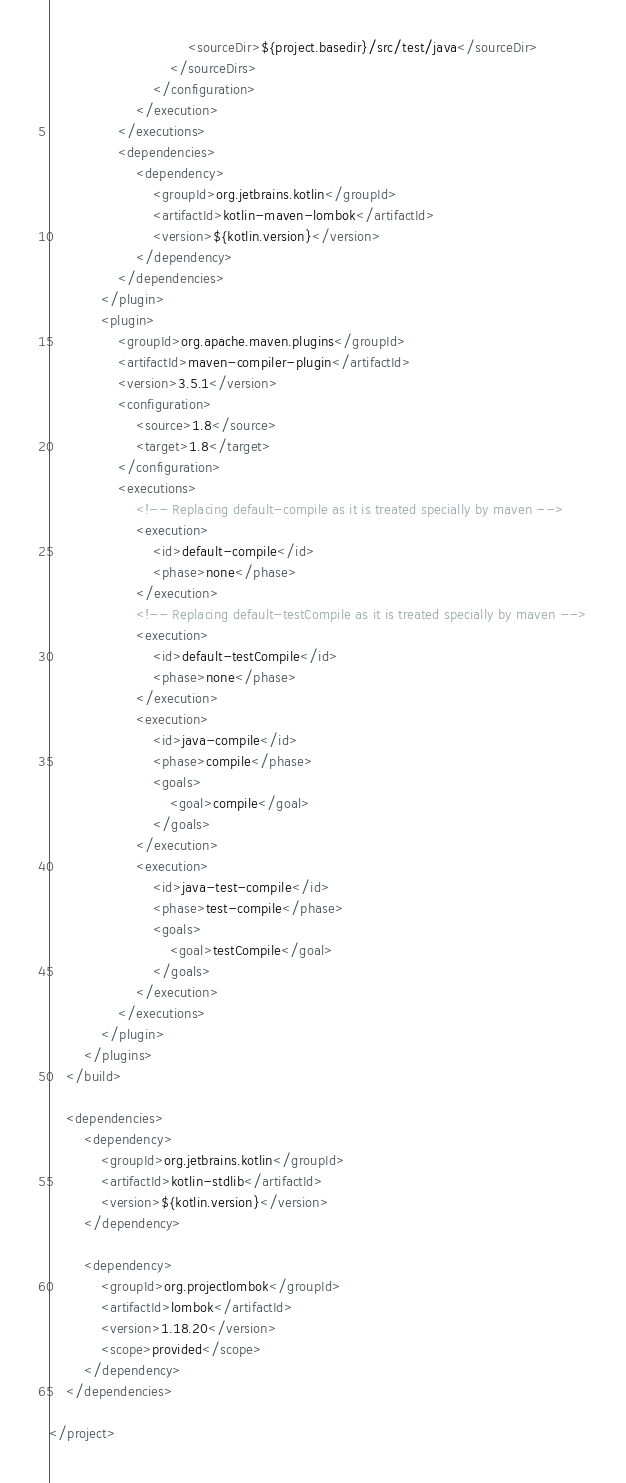Convert code to text. <code><loc_0><loc_0><loc_500><loc_500><_XML_>                                <sourceDir>${project.basedir}/src/test/java</sourceDir>
                            </sourceDirs>
                        </configuration>
                    </execution>
                </executions>
                <dependencies>
                    <dependency>
                        <groupId>org.jetbrains.kotlin</groupId>
                        <artifactId>kotlin-maven-lombok</artifactId>
                        <version>${kotlin.version}</version>
                    </dependency>
                </dependencies>
            </plugin>
            <plugin>
                <groupId>org.apache.maven.plugins</groupId>
                <artifactId>maven-compiler-plugin</artifactId>
                <version>3.5.1</version>
                <configuration>
                    <source>1.8</source>
                    <target>1.8</target>
                </configuration>
                <executions>
                    <!-- Replacing default-compile as it is treated specially by maven -->
                    <execution>
                        <id>default-compile</id>
                        <phase>none</phase>
                    </execution>
                    <!-- Replacing default-testCompile as it is treated specially by maven -->
                    <execution>
                        <id>default-testCompile</id>
                        <phase>none</phase>
                    </execution>
                    <execution>
                        <id>java-compile</id>
                        <phase>compile</phase>
                        <goals>
                            <goal>compile</goal>
                        </goals>
                    </execution>
                    <execution>
                        <id>java-test-compile</id>
                        <phase>test-compile</phase>
                        <goals>
                            <goal>testCompile</goal>
                        </goals>
                    </execution>
                </executions>
            </plugin>
        </plugins>
    </build>

    <dependencies>
        <dependency>
            <groupId>org.jetbrains.kotlin</groupId>
            <artifactId>kotlin-stdlib</artifactId>
            <version>${kotlin.version}</version>
        </dependency>

        <dependency>
            <groupId>org.projectlombok</groupId>
            <artifactId>lombok</artifactId>
            <version>1.18.20</version>
            <scope>provided</scope>
        </dependency>
    </dependencies>

</project>
</code> 